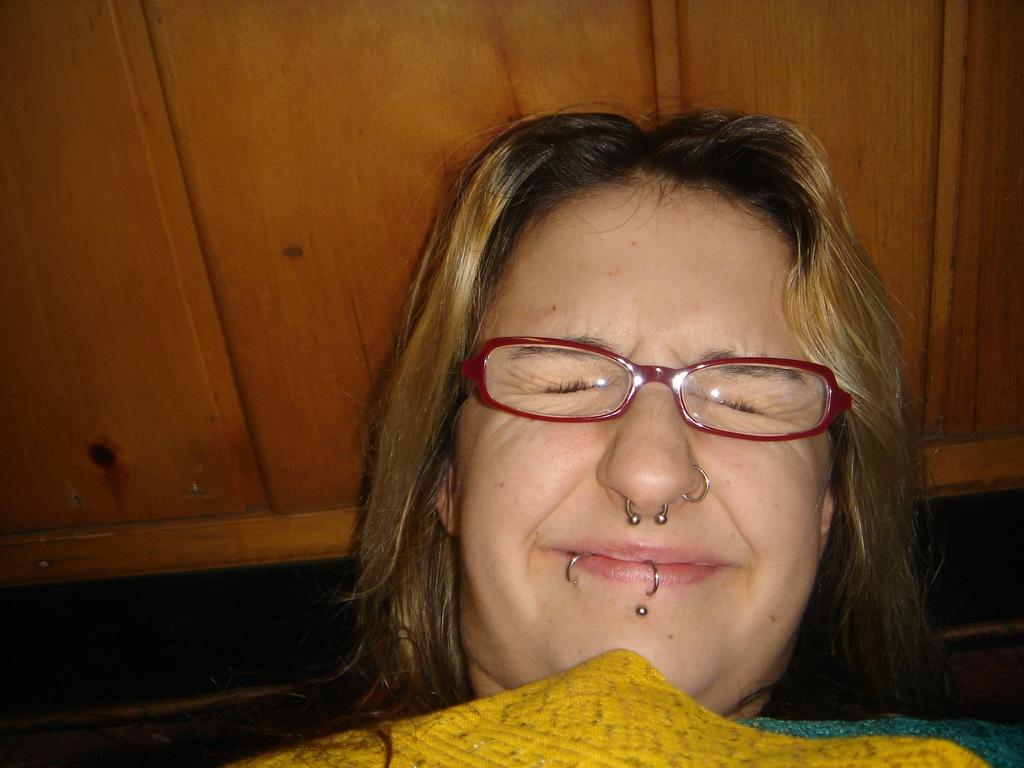Who is present in the image? There is a woman in the image. What is the woman wearing in the image? The woman is wearing spectacles in the image. What can be seen in the background of the image? There is a wooden object in the background of the image. What type of growth can be seen on the chess pieces in the image? There are no chess pieces present in the image, so it is not possible to determine if there is any growth on them. 